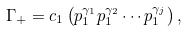<formula> <loc_0><loc_0><loc_500><loc_500>\Gamma _ { + } = c _ { 1 } \left ( p _ { 1 } ^ { \gamma _ { 1 } } p _ { 1 } ^ { \gamma _ { 2 } } \cdots p _ { 1 } ^ { \gamma _ { j } } \right ) ,</formula> 